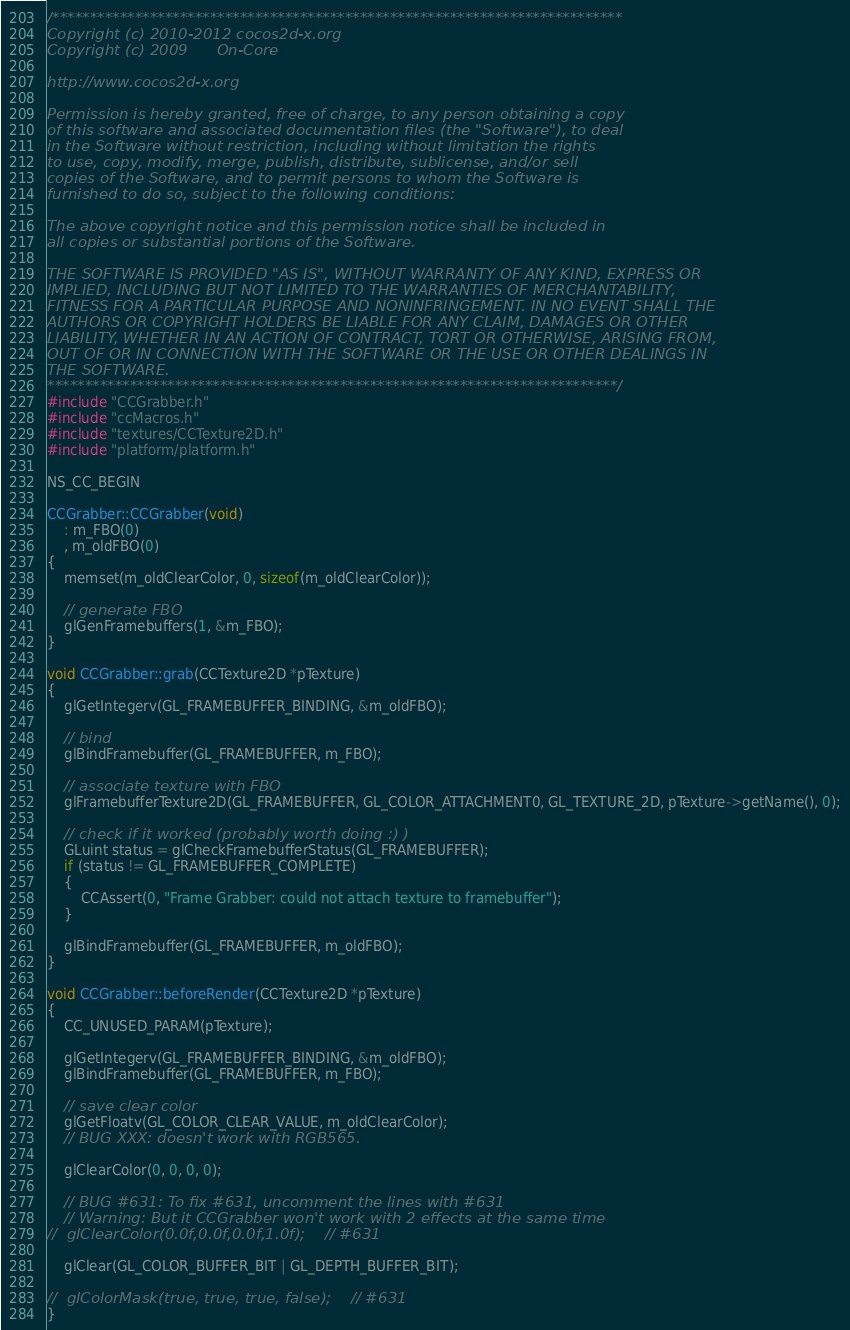Convert code to text. <code><loc_0><loc_0><loc_500><loc_500><_C++_>/****************************************************************************
Copyright (c) 2010-2012 cocos2d-x.org
Copyright (c) 2009      On-Core

http://www.cocos2d-x.org

Permission is hereby granted, free of charge, to any person obtaining a copy
of this software and associated documentation files (the "Software"), to deal
in the Software without restriction, including without limitation the rights
to use, copy, modify, merge, publish, distribute, sublicense, and/or sell
copies of the Software, and to permit persons to whom the Software is
furnished to do so, subject to the following conditions:

The above copyright notice and this permission notice shall be included in
all copies or substantial portions of the Software.

THE SOFTWARE IS PROVIDED "AS IS", WITHOUT WARRANTY OF ANY KIND, EXPRESS OR
IMPLIED, INCLUDING BUT NOT LIMITED TO THE WARRANTIES OF MERCHANTABILITY,
FITNESS FOR A PARTICULAR PURPOSE AND NONINFRINGEMENT. IN NO EVENT SHALL THE
AUTHORS OR COPYRIGHT HOLDERS BE LIABLE FOR ANY CLAIM, DAMAGES OR OTHER
LIABILITY, WHETHER IN AN ACTION OF CONTRACT, TORT OR OTHERWISE, ARISING FROM,
OUT OF OR IN CONNECTION WITH THE SOFTWARE OR THE USE OR OTHER DEALINGS IN
THE SOFTWARE.
****************************************************************************/
#include "CCGrabber.h"
#include "ccMacros.h"
#include "textures/CCTexture2D.h"
#include "platform/platform.h"

NS_CC_BEGIN

CCGrabber::CCGrabber(void)
    : m_FBO(0)
    , m_oldFBO(0)
{
    memset(m_oldClearColor, 0, sizeof(m_oldClearColor));

    // generate FBO
    glGenFramebuffers(1, &m_FBO);
}

void CCGrabber::grab(CCTexture2D *pTexture)
{
    glGetIntegerv(GL_FRAMEBUFFER_BINDING, &m_oldFBO);

    // bind
    glBindFramebuffer(GL_FRAMEBUFFER, m_FBO);

    // associate texture with FBO
    glFramebufferTexture2D(GL_FRAMEBUFFER, GL_COLOR_ATTACHMENT0, GL_TEXTURE_2D, pTexture->getName(), 0);

    // check if it worked (probably worth doing :) )
    GLuint status = glCheckFramebufferStatus(GL_FRAMEBUFFER);
    if (status != GL_FRAMEBUFFER_COMPLETE)
    {
        CCAssert(0, "Frame Grabber: could not attach texture to framebuffer");
    }

    glBindFramebuffer(GL_FRAMEBUFFER, m_oldFBO);
}

void CCGrabber::beforeRender(CCTexture2D *pTexture)
{
    CC_UNUSED_PARAM(pTexture);

    glGetIntegerv(GL_FRAMEBUFFER_BINDING, &m_oldFBO);
    glBindFramebuffer(GL_FRAMEBUFFER, m_FBO);

    // save clear color
    glGetFloatv(GL_COLOR_CLEAR_VALUE, m_oldClearColor);
    // BUG XXX: doesn't work with RGB565.

    glClearColor(0, 0, 0, 0);

    // BUG #631: To fix #631, uncomment the lines with #631
    // Warning: But it CCGrabber won't work with 2 effects at the same time
//  glClearColor(0.0f,0.0f,0.0f,1.0f);    // #631

    glClear(GL_COLOR_BUFFER_BIT | GL_DEPTH_BUFFER_BIT);

//  glColorMask(true, true, true, false);    // #631
}
</code> 